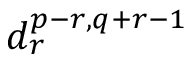<formula> <loc_0><loc_0><loc_500><loc_500>d _ { r } ^ { p - r , q + r - 1 }</formula> 